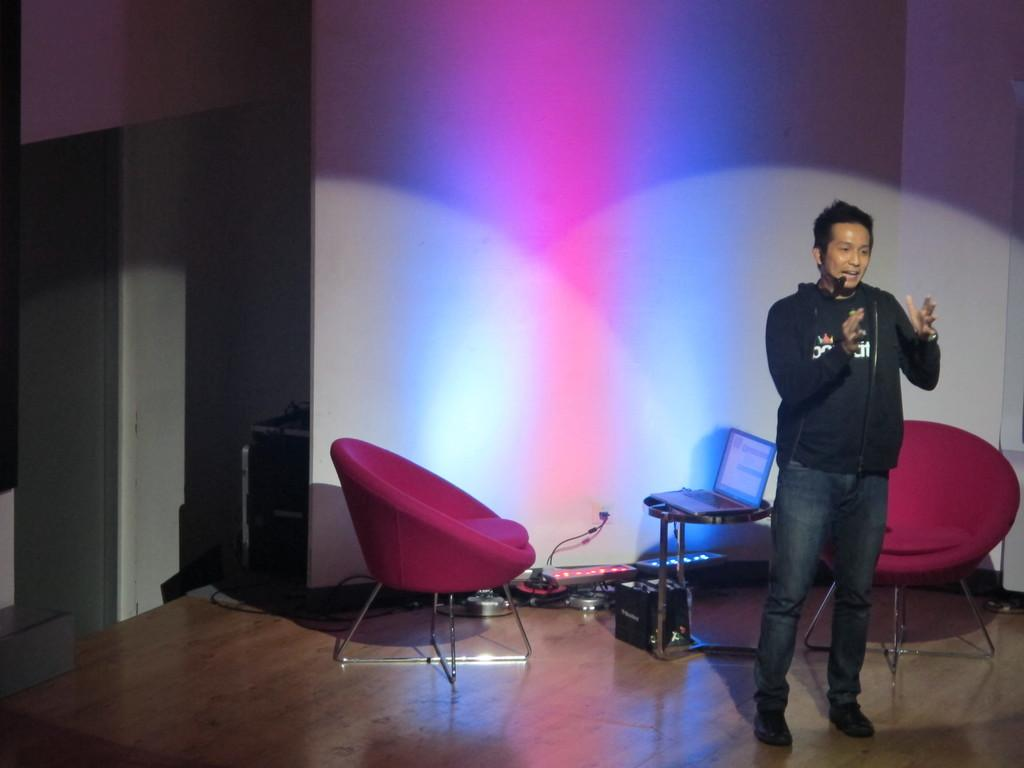What is the primary subject in the image? There is a person standing in the image. What furniture is visible in the image? There are two chairs in the image. What electronic device is present on a table in the image? There is a laptop on a table in the image. What can be found on the floor in the image? There are other objects on the floor in the image. What is visible in the background of the image? There is a wall in the background of the image. What type of calculator is being used by the person in the image? There is no calculator visible in the image; the person is not using one. 